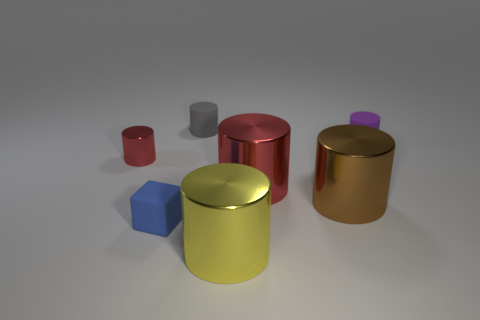Subtract 2 cylinders. How many cylinders are left? 4 Subtract all brown cylinders. How many cylinders are left? 5 Subtract all purple rubber cylinders. How many cylinders are left? 5 Subtract all cyan cylinders. Subtract all gray balls. How many cylinders are left? 6 Add 1 blocks. How many objects exist? 8 Subtract all cylinders. How many objects are left? 1 Add 5 big cylinders. How many big cylinders exist? 8 Subtract 1 blue blocks. How many objects are left? 6 Subtract all small gray matte balls. Subtract all big objects. How many objects are left? 4 Add 4 rubber blocks. How many rubber blocks are left? 5 